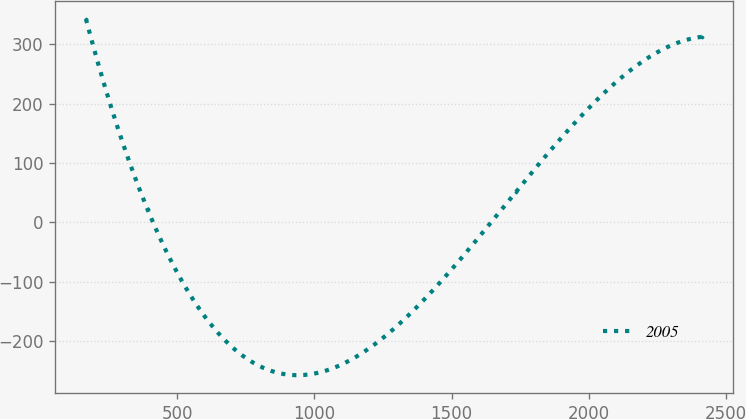Convert chart. <chart><loc_0><loc_0><loc_500><loc_500><line_chart><ecel><fcel>2005<nl><fcel>167.89<fcel>342.9<nl><fcel>392.32<fcel>21.65<nl><fcel>1734.65<fcel>51.65<nl><fcel>2412.2<fcel>312.9<nl></chart> 